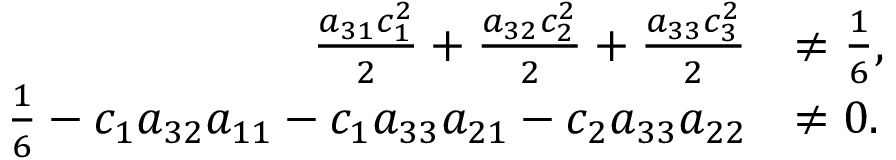<formula> <loc_0><loc_0><loc_500><loc_500>\begin{array} { r l } { \frac { a _ { 3 1 } c _ { 1 } ^ { 2 } } { 2 } + \frac { a _ { 3 2 } c _ { 2 } ^ { 2 } } { 2 } + \frac { a _ { 3 3 } c _ { 3 } ^ { 2 } } { 2 } } & { \ne \frac { 1 } { 6 } , } \\ { \frac { 1 } { 6 } - c _ { 1 } a _ { 3 2 } a _ { 1 1 } - c _ { 1 } a _ { 3 3 } a _ { 2 1 } - c _ { 2 } a _ { 3 3 } a _ { 2 2 } } & { \ne 0 . } \end{array}</formula> 